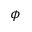<formula> <loc_0><loc_0><loc_500><loc_500>\phi</formula> 